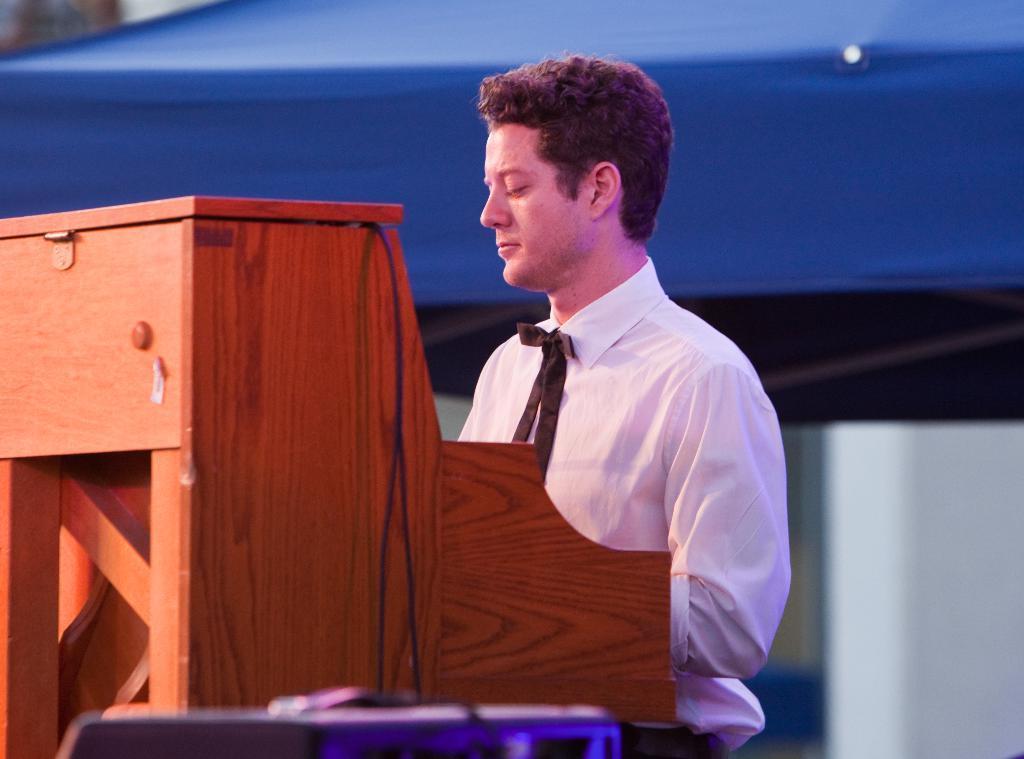Describe this image in one or two sentences. Here there is a man wearing white color shirt, this is wooden structure. 